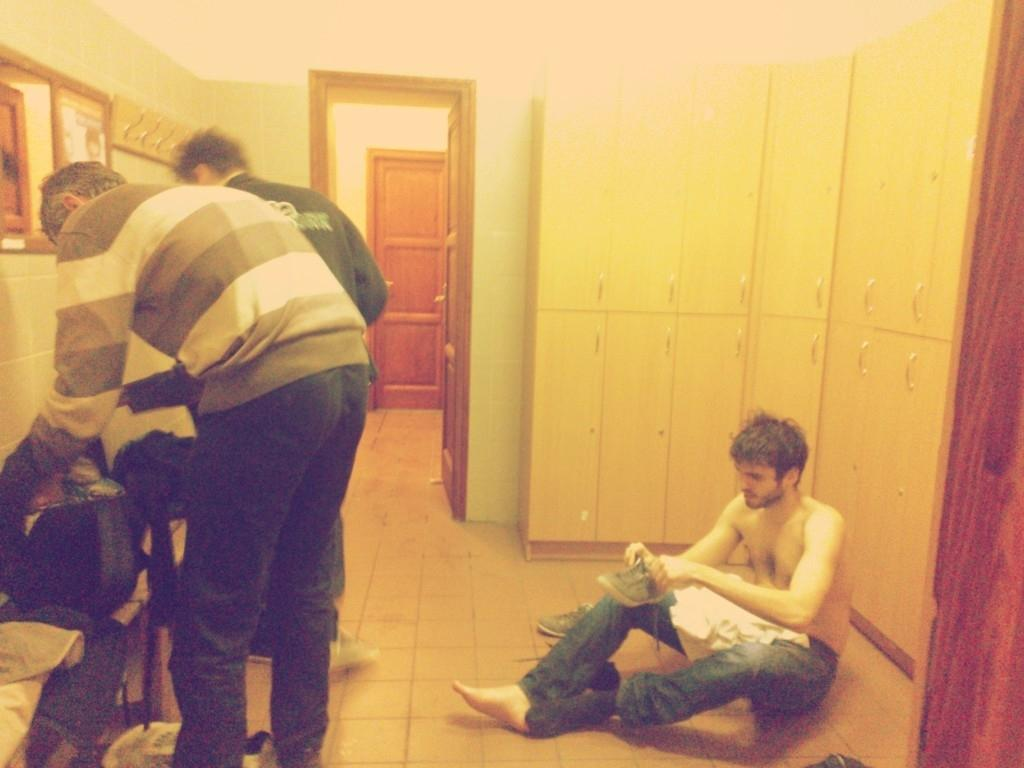What is the man in the image doing? The man is sitting on the ground in the image. What is the man holding? The man is holding a shoe. How many men are standing in the image? There are men standing in the image. What is on the table in the image? There are bags on a table in the image. What is on the wall in the image? There is a mirror on the wall in the image. What type of brass instrument is the man playing in the image? There is no brass instrument present in the image; the man is holding a shoe. 